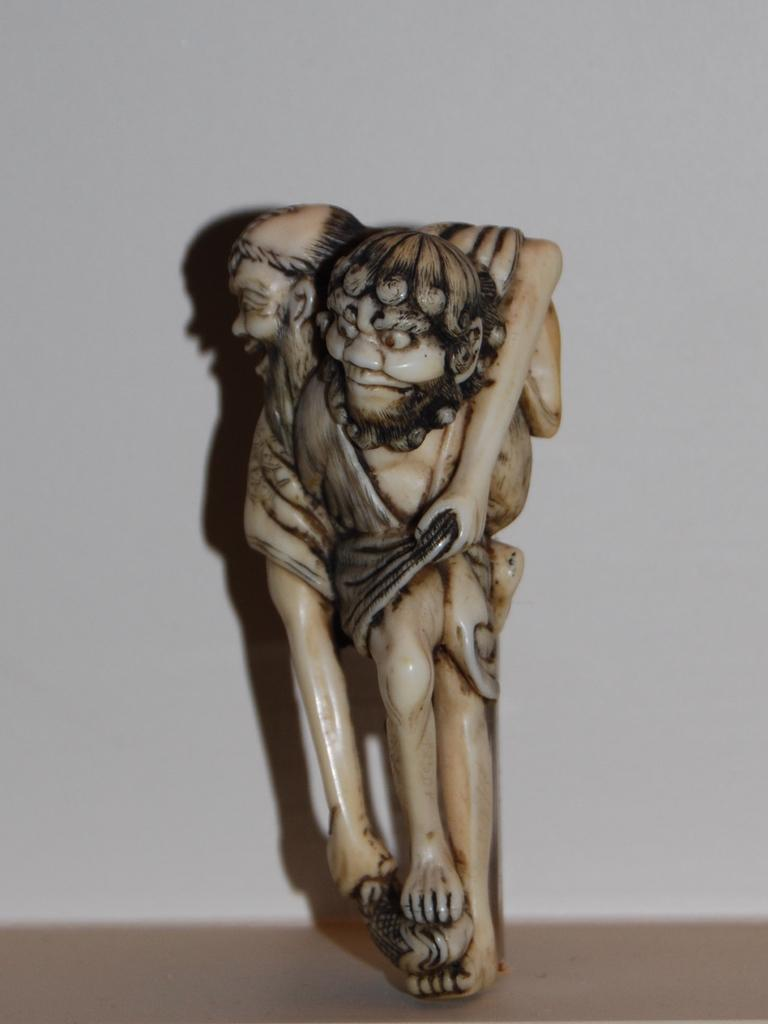What type of object is in the image? There is a small toy in the image. What material is the toy made of? The toy is made of stone. What color is the toy? The toy is white in color. What type of alarm can be heard going off in the image? There is no alarm present in the image, so it cannot be heard. 